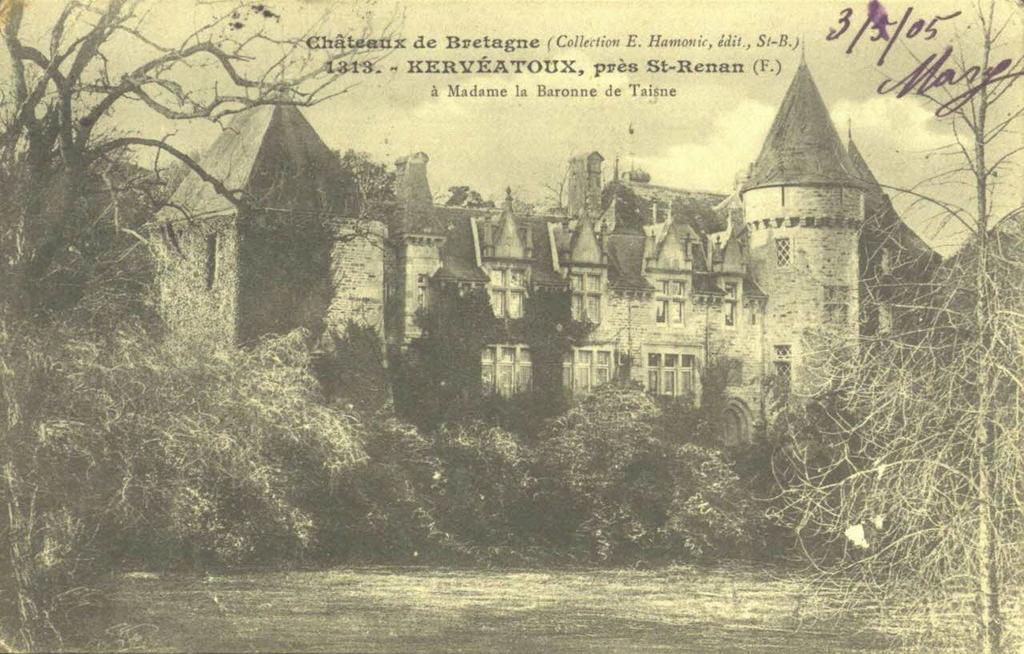What is the color scheme of the image? The image is black and white. What is the main subject in the middle of the image? There is a big house in the middle of the image. What type of natural elements can be seen in the image? There are trees in the image. What is visible at the top of the image? The sky is visible at the top of the image. What else is featured in the image besides the house and trees? There is text in the image. Can you tell me how many donkeys are depicted in the image? There are no donkeys present in the image; it features a big house, trees, and text. What type of sign is shown in the image? There is no sign present in the image; it is a black and white image with a house, trees, and text. 